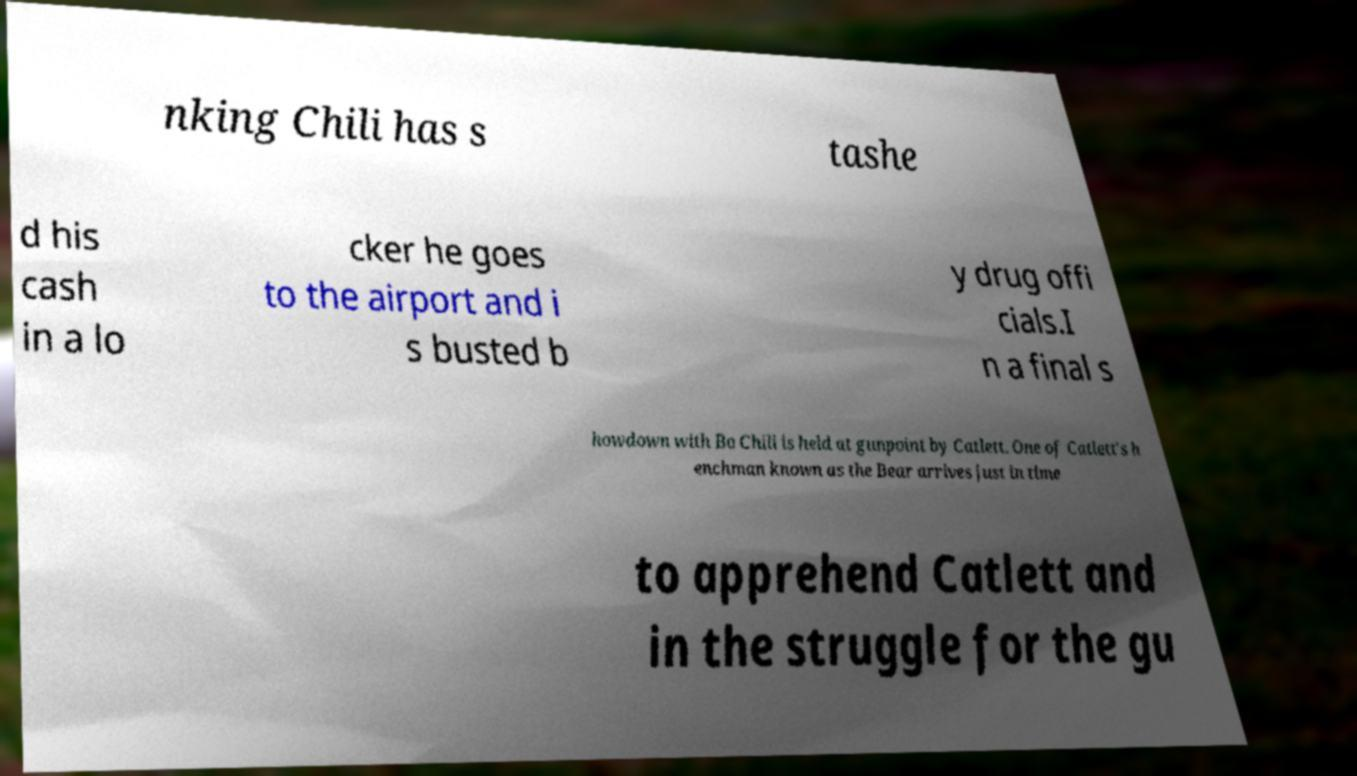For documentation purposes, I need the text within this image transcribed. Could you provide that? nking Chili has s tashe d his cash in a lo cker he goes to the airport and i s busted b y drug offi cials.I n a final s howdown with Bo Chili is held at gunpoint by Catlett. One of Catlett's h enchman known as the Bear arrives just in time to apprehend Catlett and in the struggle for the gu 